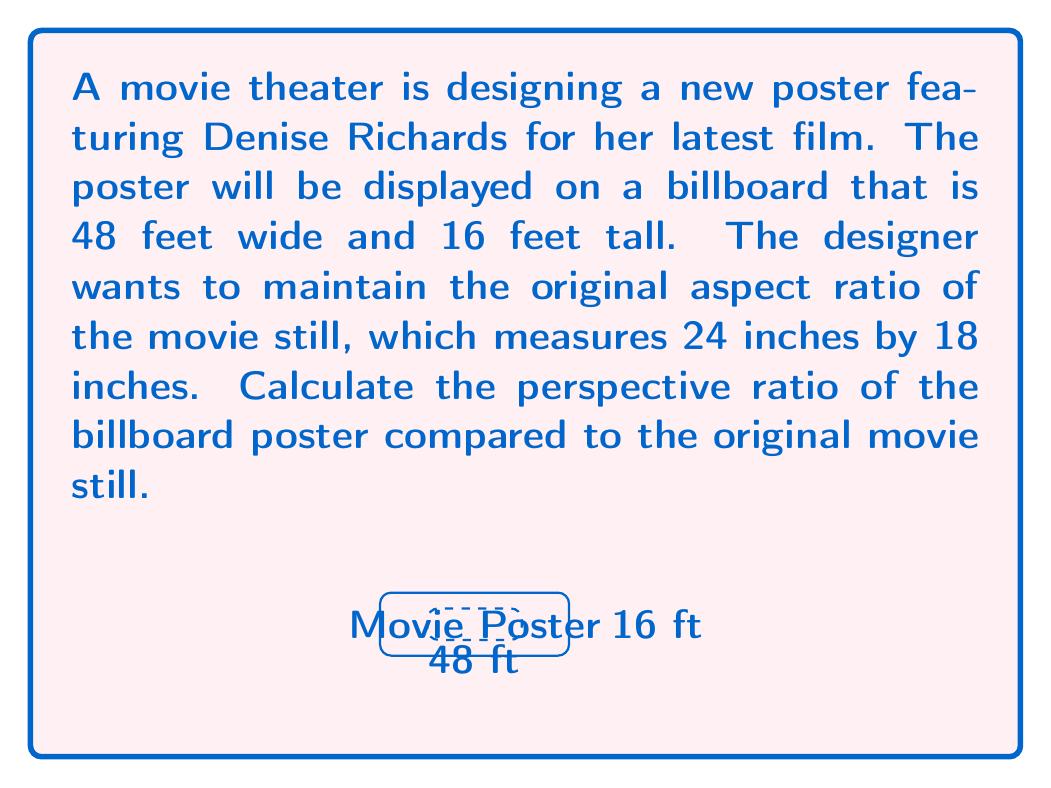Could you help me with this problem? To calculate the perspective ratio, we need to compare the scaling factors of width and height from the original still to the billboard poster.

Step 1: Convert all measurements to the same unit (feet).
Original still: 24 inches = 2 feet, 18 inches = 1.5 feet

Step 2: Calculate the scaling factor for width.
$\text{Width scaling factor} = \frac{\text{Billboard width}}{\text{Original width}} = \frac{48 \text{ ft}}{2 \text{ ft}} = 24$

Step 3: Calculate the scaling factor for height.
$\text{Height scaling factor} = \frac{\text{Billboard height}}{\text{Original height}} = \frac{16 \text{ ft}}{1.5 \text{ ft}} = \frac{32}{3} \approx 10.67$

Step 4: Calculate the perspective ratio by dividing the larger scaling factor by the smaller one.
$\text{Perspective ratio} = \frac{\text{Width scaling factor}}{\text{Height scaling factor}} = \frac{24}{\frac{32}{3}} = \frac{24 \cdot 3}{32} = \frac{9}{4} = 2.25$

This means the width is scaled 2.25 times more than the height, creating a wider perspective on the billboard compared to the original still.
Answer: $\frac{9}{4}$ or $2.25:1$ 